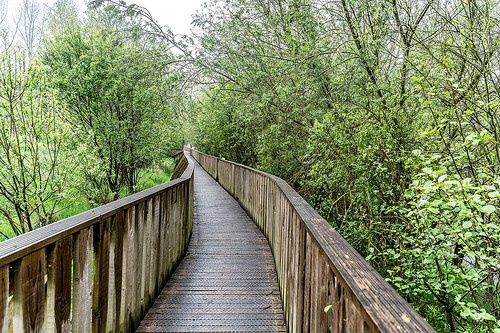<image>
Is there a bridge next to the trees? Yes. The bridge is positioned adjacent to the trees, located nearby in the same general area. 